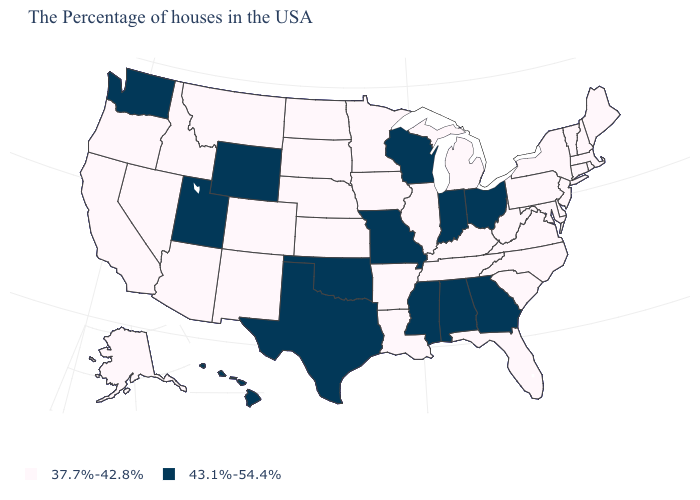What is the lowest value in the South?
Be succinct. 37.7%-42.8%. Which states have the highest value in the USA?
Answer briefly. Ohio, Georgia, Indiana, Alabama, Wisconsin, Mississippi, Missouri, Oklahoma, Texas, Wyoming, Utah, Washington, Hawaii. What is the value of Michigan?
Keep it brief. 37.7%-42.8%. What is the value of New Mexico?
Give a very brief answer. 37.7%-42.8%. What is the value of Ohio?
Quick response, please. 43.1%-54.4%. What is the highest value in states that border Louisiana?
Keep it brief. 43.1%-54.4%. Which states have the highest value in the USA?
Quick response, please. Ohio, Georgia, Indiana, Alabama, Wisconsin, Mississippi, Missouri, Oklahoma, Texas, Wyoming, Utah, Washington, Hawaii. What is the highest value in the MidWest ?
Short answer required. 43.1%-54.4%. What is the value of Connecticut?
Give a very brief answer. 37.7%-42.8%. What is the highest value in the MidWest ?
Keep it brief. 43.1%-54.4%. What is the value of North Carolina?
Write a very short answer. 37.7%-42.8%. What is the lowest value in the USA?
Give a very brief answer. 37.7%-42.8%. Name the states that have a value in the range 37.7%-42.8%?
Be succinct. Maine, Massachusetts, Rhode Island, New Hampshire, Vermont, Connecticut, New York, New Jersey, Delaware, Maryland, Pennsylvania, Virginia, North Carolina, South Carolina, West Virginia, Florida, Michigan, Kentucky, Tennessee, Illinois, Louisiana, Arkansas, Minnesota, Iowa, Kansas, Nebraska, South Dakota, North Dakota, Colorado, New Mexico, Montana, Arizona, Idaho, Nevada, California, Oregon, Alaska. Does Alabama have the highest value in the South?
Give a very brief answer. Yes. Name the states that have a value in the range 43.1%-54.4%?
Give a very brief answer. Ohio, Georgia, Indiana, Alabama, Wisconsin, Mississippi, Missouri, Oklahoma, Texas, Wyoming, Utah, Washington, Hawaii. 